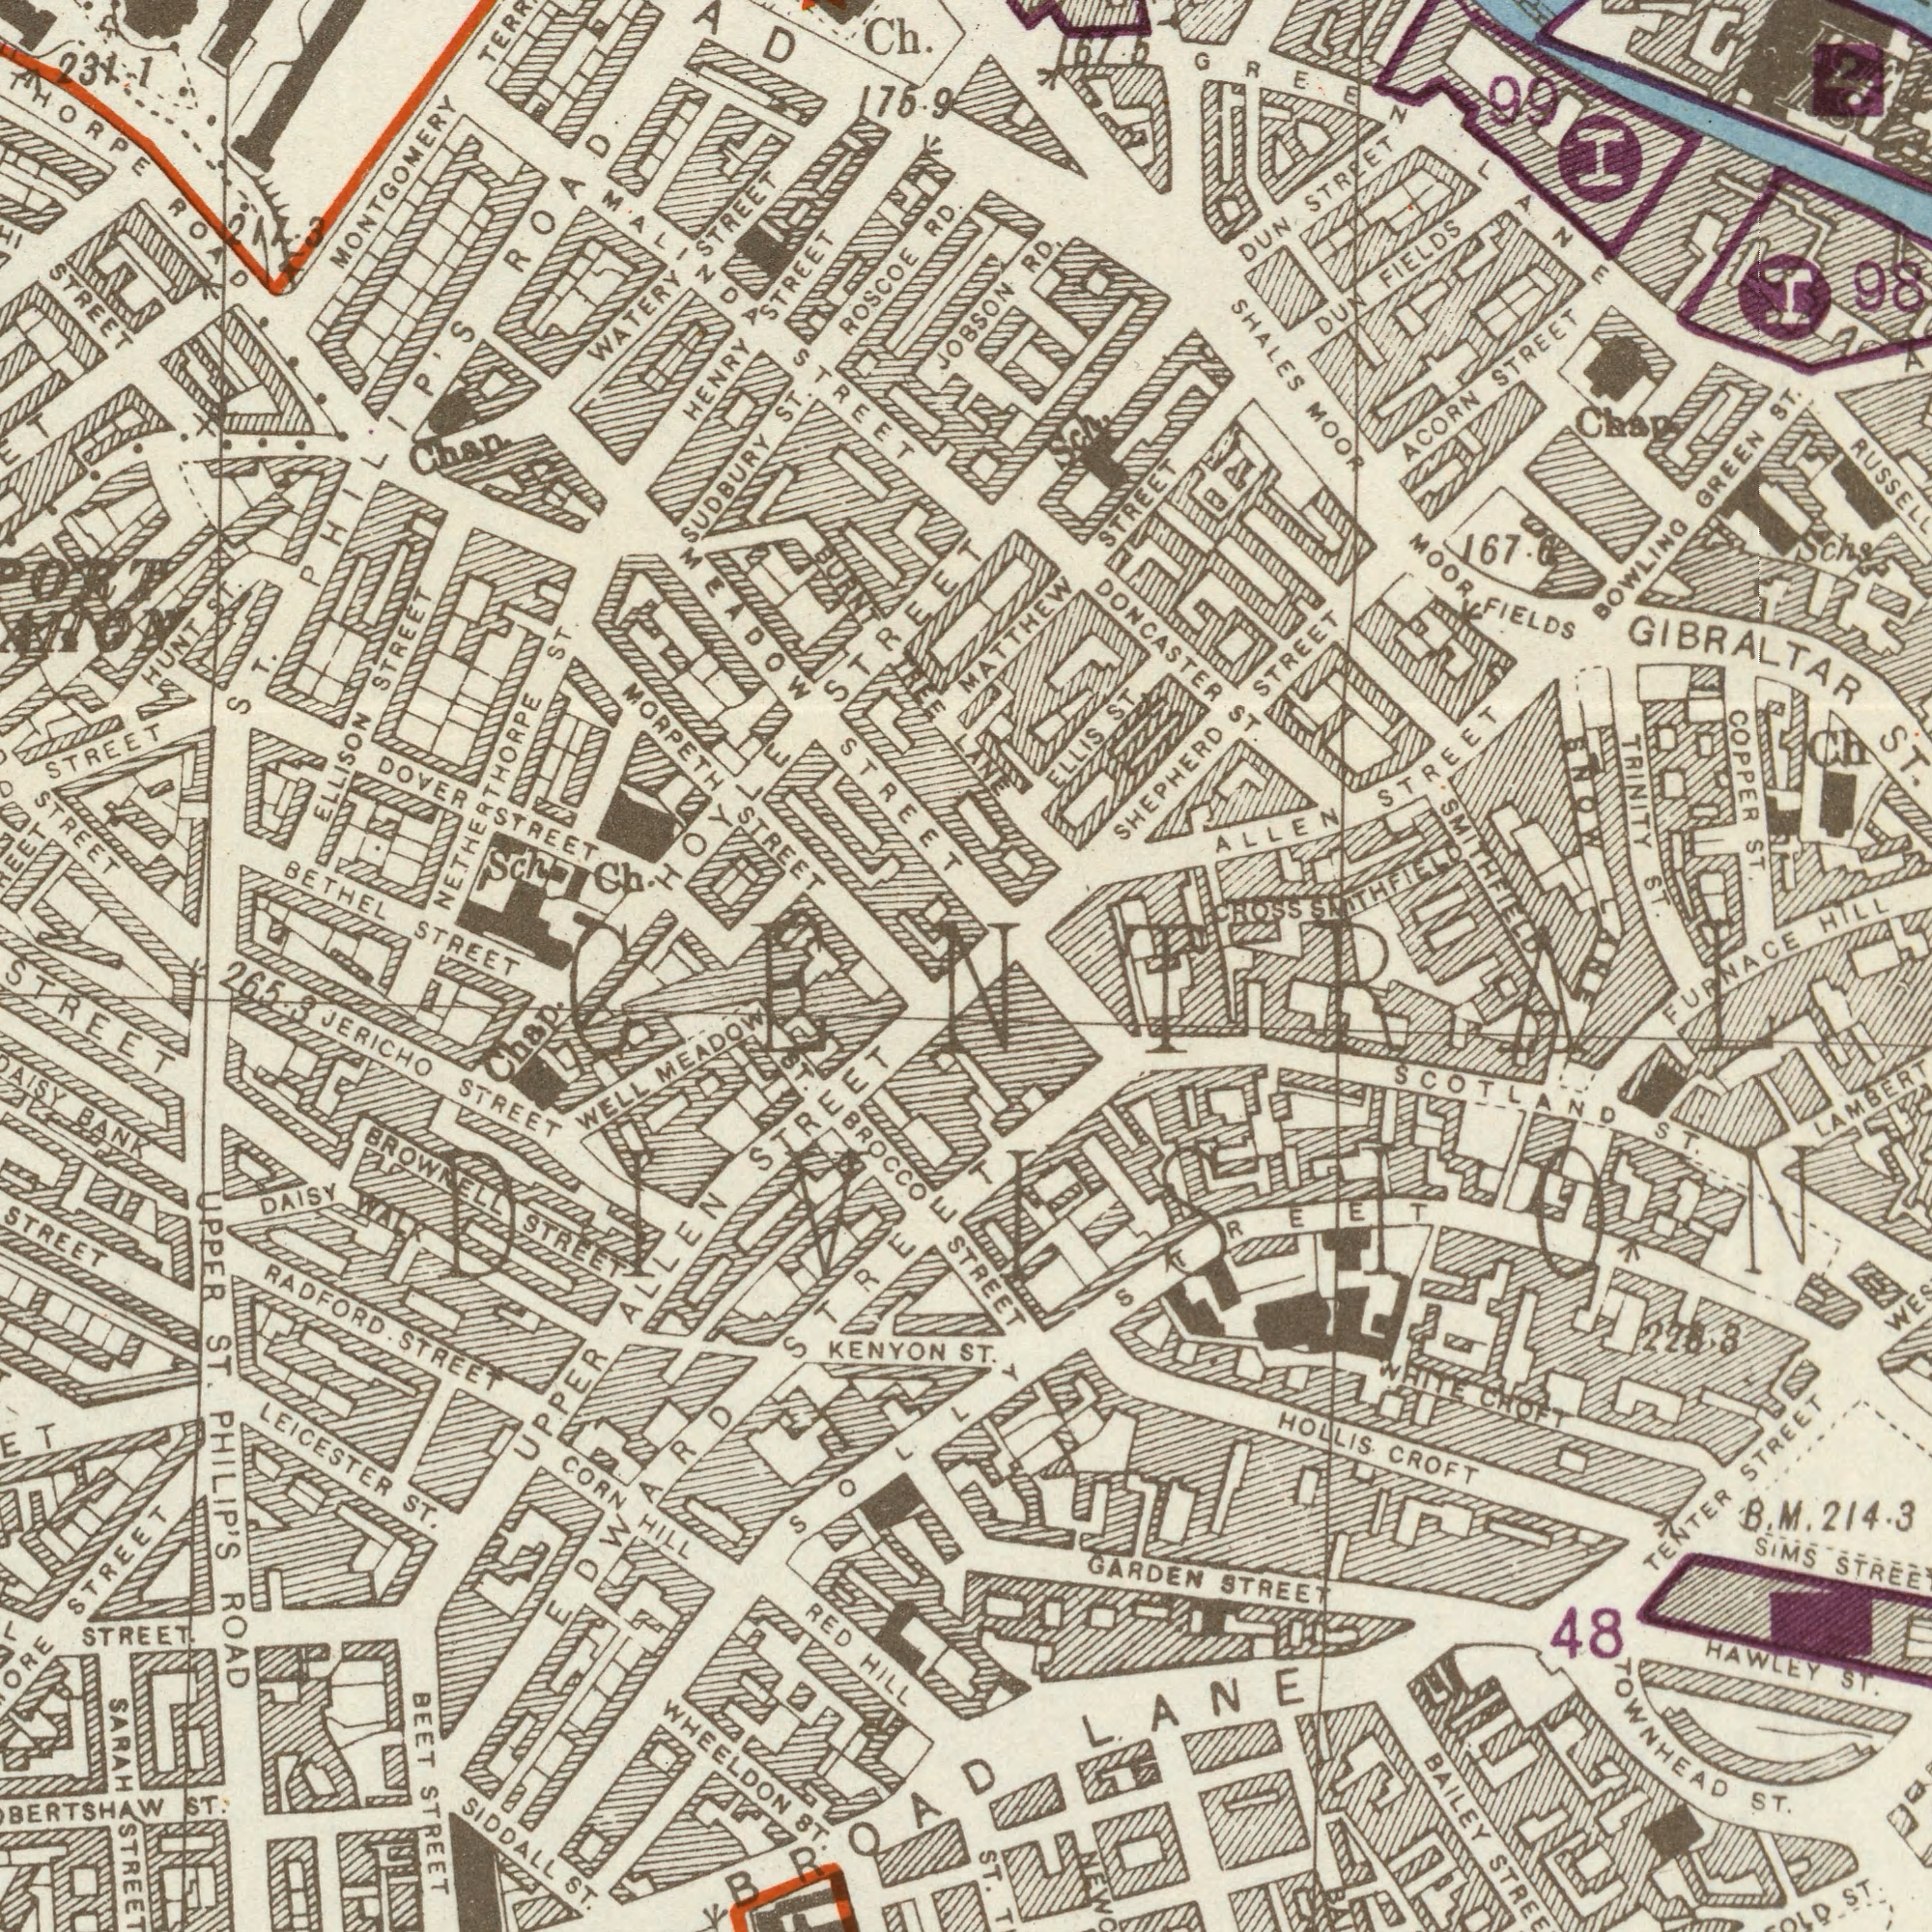What text can you see in the top-left section? BETHEL STREET ROSCOE RD. Ch. SUDBURY ST. MONTGOMERY ELLISON STREET HENRY STREET THORPE ROAD STREET Chan. DOVER STREET STREET MALINDA STREET WATERY STREET NETHERTHORPE ST. MEADOW STREET STREET 231.1 MORPETH STREET HOYLE STREET HUNT ST. 175.9 ST. PHILIP'S ROAD 217.3 BURNT TREE Ch. Sch STREET What text is shown in the top-right quadrant? TRINITY ST. ALLEN STREET SHALES MOOR COPPER ST. BOWLING GREEN ST. HILL ACORN STREET MATTHEW STREET DUN FIELDS SHEPHERD STREET ELLIS ST. GIBRALTAR ST. Chap 167.6 Ch DUN STREET DONCASTER ST. MOOR FIELDS x 98 99 GREEN LANE x LANE 167.5 Schs SNOW LANE SMITHFIELD CROSS SMITHFIELD JOBSON RD. What text is shown in the bottom-right quadrant? FURNACE ST. STREET SCOTLAND ST. BAILEY GARDEN STREET LAMBERT HAWLEY ST. LANE TENTER STREET SIMS STREET 228.3 TOWNHEAD ST. HOLLIS. CROFT B. M. 214.3 ST. 48 ST. WHITE CROFT CENTRAL DIVISION STREET What text can you see in the bottom-left section? Chap. PHILIP'S ROAD LEICESTER ST. UPPER ALLEN STREET ST. RADFORD. STREET STREET STREET UPPER ST. SIDDALL ST. KENYON SARAH STREET BEET STREET STREET. WELL MEADOW DAISY WALK BROWNELL STREET JERICHO STREET CORN HILL STREET WHEELDON ST. RED HILL BANK ST. BROCCO BROAD 265.3 SOLLY EDWARD STREET 